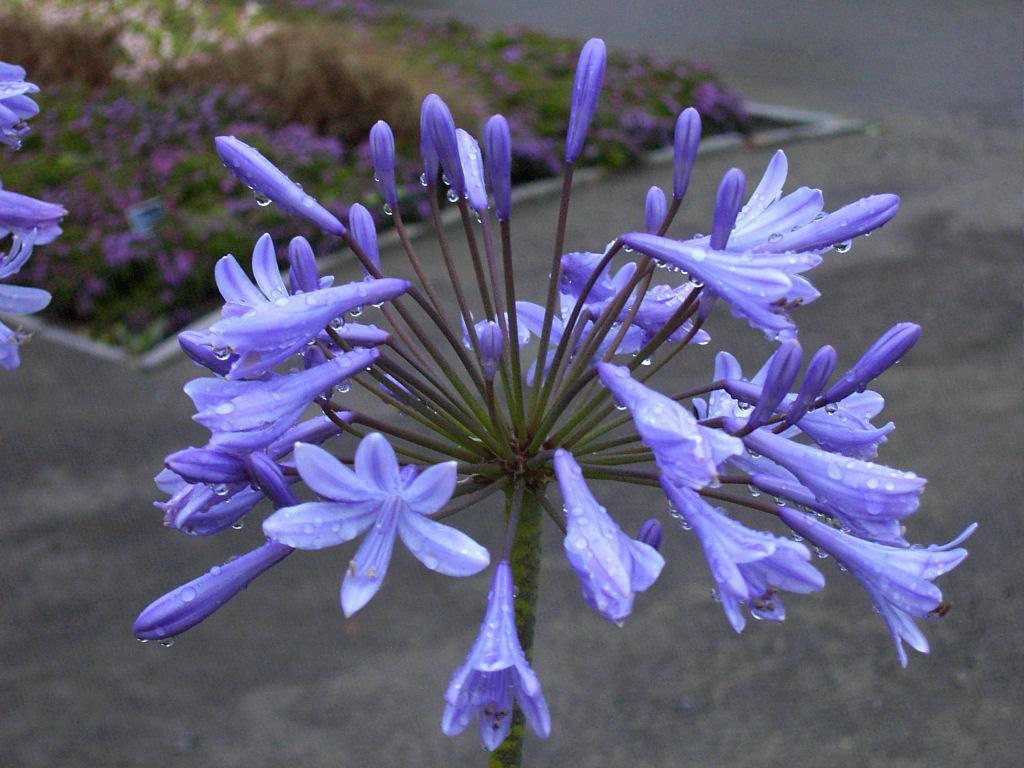Can you describe this image briefly? In the image there are purple flowers to a plant and behind there are many flower plants on the land. 